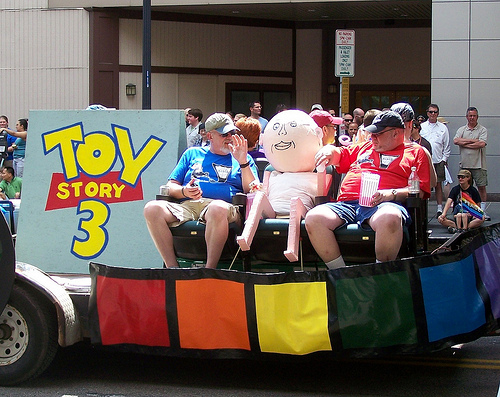<image>
Can you confirm if the man is in front of the dummy? No. The man is not in front of the dummy. The spatial positioning shows a different relationship between these objects. 